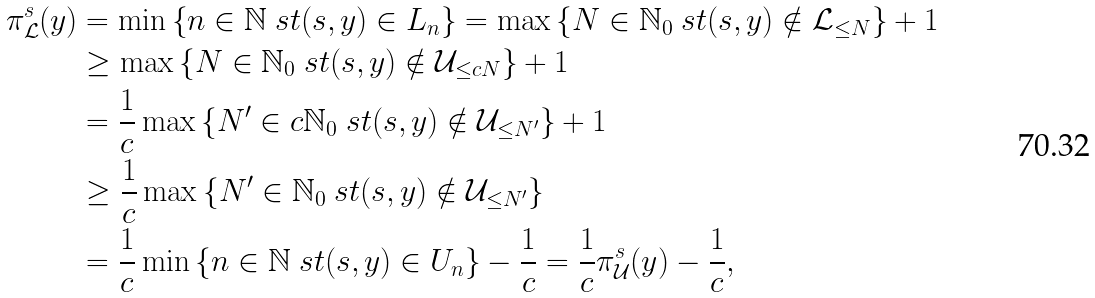Convert formula to latex. <formula><loc_0><loc_0><loc_500><loc_500>\pi ^ { s } _ { \mathcal { L } } ( y ) & = \min \left \{ n \in \mathbb { N } \ s t ( s , y ) \in L _ { n } \right \} = \max \left \{ N \in \mathbb { N } _ { 0 } \ s t ( s , y ) \notin \mathcal { L } _ { \leq N } \right \} + 1 \\ & \geq \max \left \{ N \in \mathbb { N } _ { 0 } \ s t ( s , y ) \notin \mathcal { U } _ { \leq c N } \right \} + 1 \\ & = \frac { 1 } { c } \max \left \{ N ^ { \prime } \in c \mathbb { N } _ { 0 } \ s t ( s , y ) \notin \mathcal { U } _ { \leq N ^ { \prime } } \right \} + 1 \\ & \geq \frac { 1 } { c } \max \left \{ N ^ { \prime } \in \mathbb { N } _ { 0 } \ s t ( s , y ) \notin \mathcal { U } _ { \leq N ^ { \prime } } \right \} \\ & = \frac { 1 } { c } \min \left \{ n \in \mathbb { N } \ s t ( s , y ) \in U _ { n } \right \} - \frac { 1 } { c } = \frac { 1 } { c } \pi ^ { s } _ { \mathcal { U } } ( y ) - \frac { 1 } { c } ,</formula> 